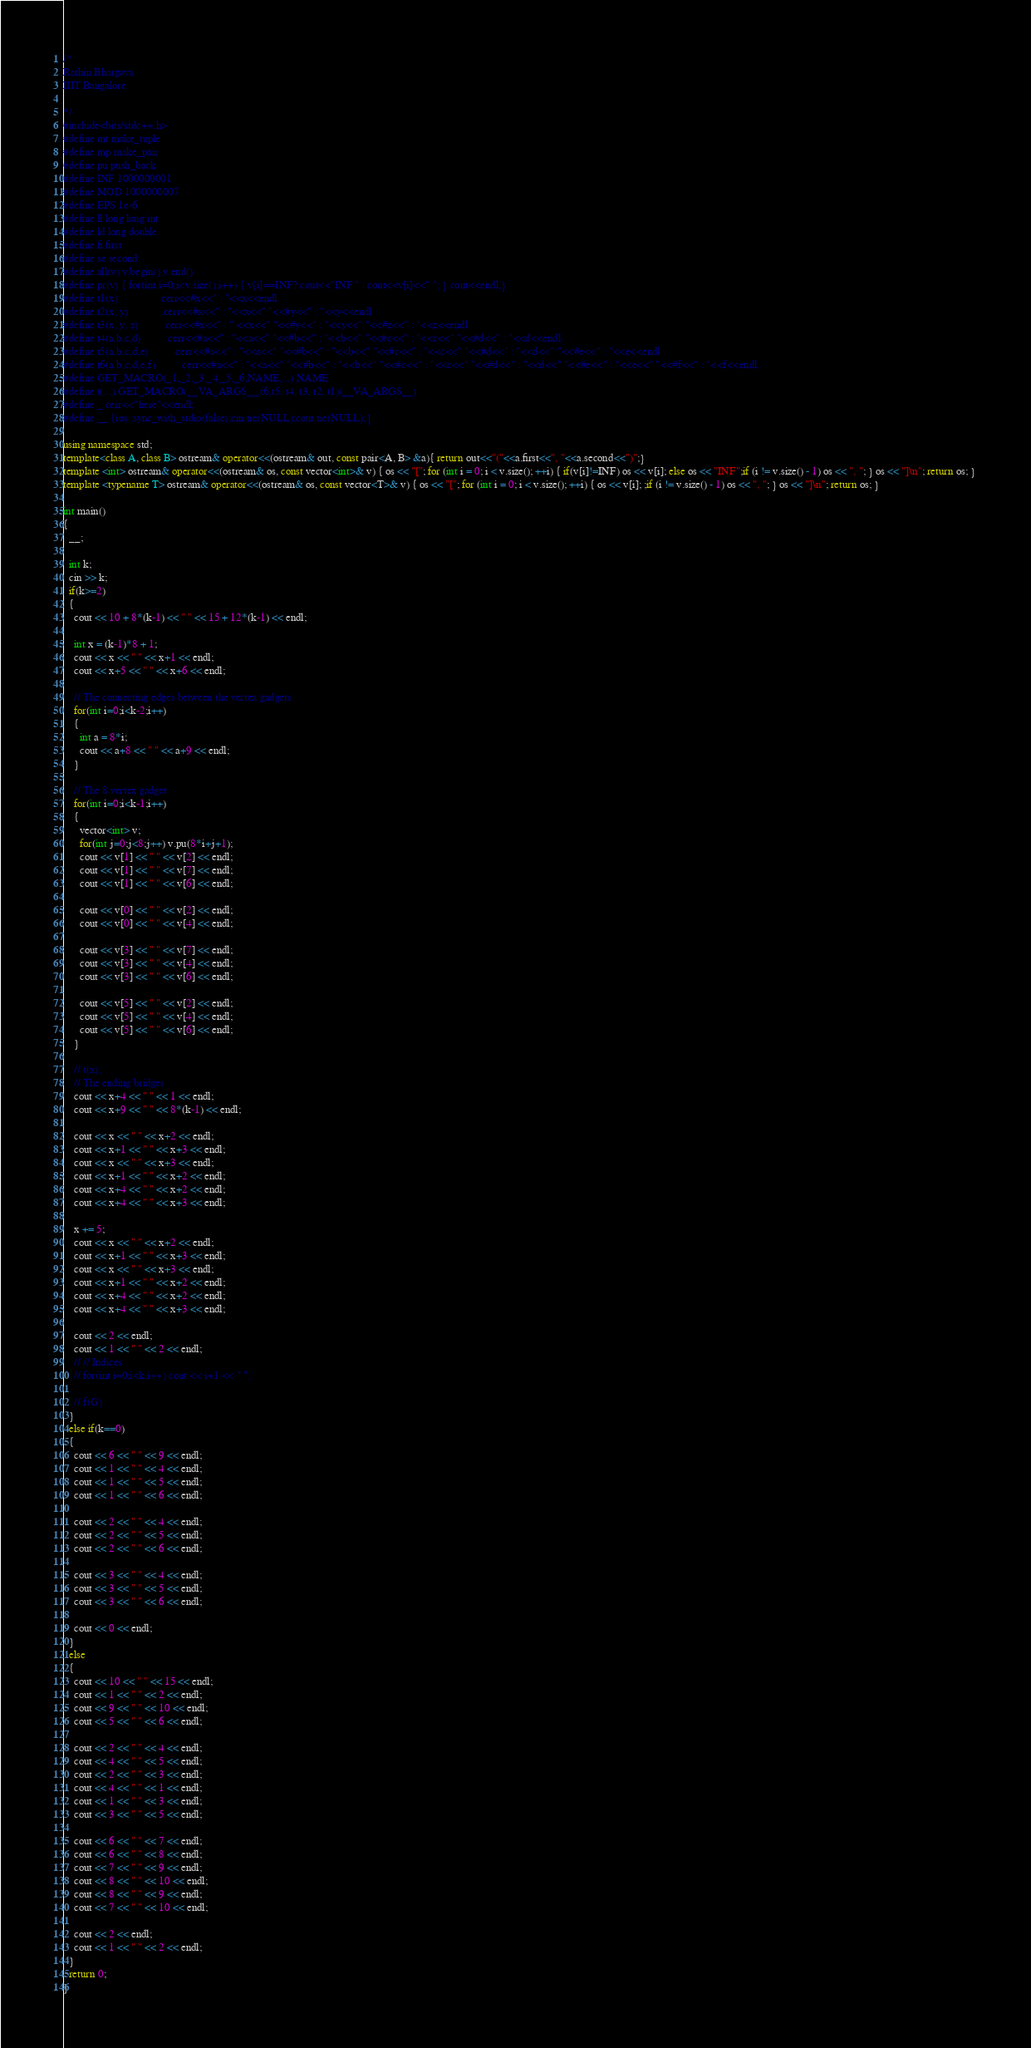<code> <loc_0><loc_0><loc_500><loc_500><_C++_>/*
Rathin Bhargava
IIIT Bangalore

*/
#include<bits/stdc++.h>
#define mt make_tuple
#define mp make_pair
#define pu push_back
#define INF 1000000001
#define MOD 1000000007
#define EPS 1e-6
#define ll long long int
#define ld long double
#define fi first
#define se second
#define all(v) v.begin(),v.end()
#define pr(v) { for(int i=0;i<v.size();i++) { v[i]==INF? cout<<"INF " : cout<<v[i]<<" "; } cout<<endl;}
#define t1(x)                cerr<<#x<<" : "<<x<<endl
#define t2(x, y)             cerr<<#x<<" : "<<x<<" "<<#y<<" : "<<y<<endl
#define t3(x, y, z)          cerr<<#x<<" : " <<x<<" "<<#y<<" : "<<y<<" "<<#z<<" : "<<z<<endl
#define t4(a,b,c,d)          cerr<<#a<<" : "<<a<<" "<<#b<<" : "<<b<<" "<<#c<<" : "<<c<<" "<<#d<<" : "<<d<<endl
#define t5(a,b,c,d,e)          cerr<<#a<<" : "<<a<<" "<<#b<<" : "<<b<<" "<<#c<<" : "<<c<<" "<<#d<<" : "<<d<<" "<<#e<<" : "<<e<<endl
#define t6(a,b,c,d,e,f)          cerr<<#a<<" : "<<a<<" "<<#b<<" : "<<b<<" "<<#c<<" : "<<c<<" "<<#d<<" : "<<d<<" "<<#e<<" : "<<e<<" "<<#f<<" : "<<f<<endl
#define GET_MACRO(_1,_2,_3,_4,_5,_6,NAME,...) NAME
#define t(...) GET_MACRO(__VA_ARGS__,t6,t5, t4, t3, t2, t1)(__VA_ARGS__)
#define _ cerr<<"here"<<endl;
#define __ {ios::sync_with_stdio(false);cin.tie(NULL);cout.tie(NULL);}

using namespace std;
template<class A, class B> ostream& operator<<(ostream& out, const pair<A, B> &a){ return out<<"("<<a.first<<", "<<a.second<<")";}
template <int> ostream& operator<<(ostream& os, const vector<int>& v) { os << "["; for (int i = 0; i < v.size(); ++i) { if(v[i]!=INF) os << v[i]; else os << "INF";if (i != v.size() - 1) os << ", "; } os << "]\n"; return os; } 
template <typename T> ostream& operator<<(ostream& os, const vector<T>& v) { os << "["; for (int i = 0; i < v.size(); ++i) { os << v[i]; ;if (i != v.size() - 1) os << ", "; } os << "]\n"; return os; } 

int main()
{
  __;

  int k;
  cin >> k;
  if(k>=2)
  {
    cout << 10 + 8*(k-1) << " " << 15 + 12*(k-1) << endl;

    int x = (k-1)*8 + 1;
    cout << x << " " << x+1 << endl;
    cout << x+5 << " " << x+6 << endl;

    // The connecting edges between the vertex gadgets
    for(int i=0;i<k-2;i++)
    {
      int a = 8*i;
      cout << a+8 << " " << a+9 << endl;
    }

    // The 8 vertex gadget
    for(int i=0;i<k-1;i++)
    {
      vector<int> v;
      for(int j=0;j<8;j++) v.pu(8*i+j+1);
      cout << v[1] << " " << v[2] << endl;
      cout << v[1] << " " << v[7] << endl;
      cout << v[1] << " " << v[6] << endl;

      cout << v[0] << " " << v[2] << endl;
      cout << v[0] << " " << v[4] << endl;

      cout << v[3] << " " << v[7] << endl;
      cout << v[3] << " " << v[4] << endl;
      cout << v[3] << " " << v[6] << endl;

      cout << v[5] << " " << v[2] << endl;
      cout << v[5] << " " << v[4] << endl;
      cout << v[5] << " " << v[6] << endl;
    }

    // t(x);
    // The ending bridges
    cout << x+4 << " " << 1 << endl;
    cout << x+9 << " " << 8*(k-1) << endl;

    cout << x << " " << x+2 << endl;
    cout << x+1 << " " << x+3 << endl;
    cout << x << " " << x+3 << endl;
    cout << x+1 << " " << x+2 << endl;
    cout << x+4 << " " << x+2 << endl;
    cout << x+4 << " " << x+3 << endl;

    x += 5;
    cout << x << " " << x+2 << endl;
    cout << x+1 << " " << x+3 << endl;
    cout << x << " " << x+3 << endl;
    cout << x+1 << " " << x+2 << endl;
    cout << x+4 << " " << x+2 << endl;
    cout << x+4 << " " << x+3 << endl;

    cout << 2 << endl;
    cout << 1 << " " << 2 << endl;
    // // Indices
    // for(int i=0;i<k;i++) cout << i+1 << " ";

    // f(G)
  }
  else if(k==0)
  {
    cout << 6 << " " << 9 << endl;
    cout << 1 << " " << 4 << endl;
    cout << 1 << " " << 5 << endl;
    cout << 1 << " " << 6 << endl;
    
    cout << 2 << " " << 4 << endl;
    cout << 2 << " " << 5 << endl;
    cout << 2 << " " << 6 << endl;

    cout << 3 << " " << 4 << endl;
    cout << 3 << " " << 5 << endl;
    cout << 3 << " " << 6 << endl;
    
    cout << 0 << endl;
  }
  else
  {
    cout << 10 << " " << 15 << endl;
    cout << 1 << " " << 2 << endl;
    cout << 9 << " " << 10 << endl;
    cout << 5 << " " << 6 << endl;

    cout << 2 << " " << 4 << endl;
    cout << 4 << " " << 5 << endl;
    cout << 2 << " " << 3 << endl;
    cout << 4 << " " << 1 << endl;
    cout << 1 << " " << 3 << endl;
    cout << 3 << " " << 5 << endl;

    cout << 6 << " " << 7 << endl;
    cout << 6 << " " << 8 << endl;
    cout << 7 << " " << 9 << endl;
    cout << 8 << " " << 10 << endl;
    cout << 8 << " " << 9 << endl;
    cout << 7 << " " << 10 << endl;

    cout << 2 << endl;
    cout << 1 << " " << 2 << endl;
  }
  return 0;
}







</code> 